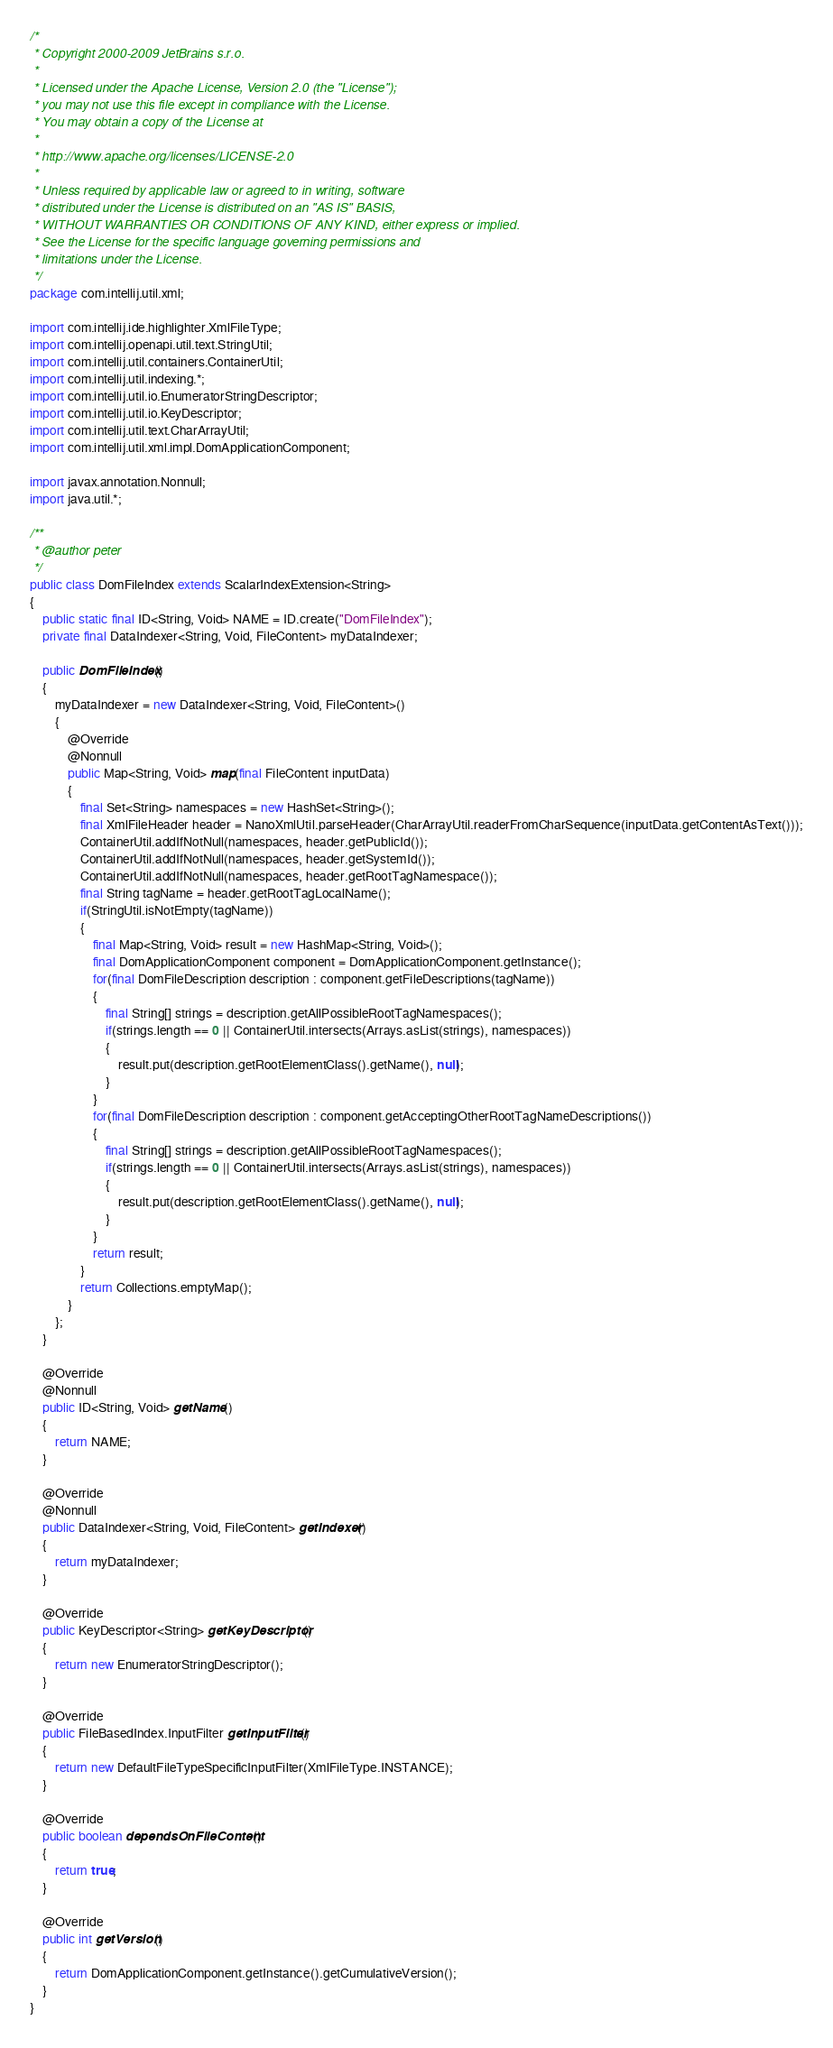<code> <loc_0><loc_0><loc_500><loc_500><_Java_>/*
 * Copyright 2000-2009 JetBrains s.r.o.
 *
 * Licensed under the Apache License, Version 2.0 (the "License");
 * you may not use this file except in compliance with the License.
 * You may obtain a copy of the License at
 *
 * http://www.apache.org/licenses/LICENSE-2.0
 *
 * Unless required by applicable law or agreed to in writing, software
 * distributed under the License is distributed on an "AS IS" BASIS,
 * WITHOUT WARRANTIES OR CONDITIONS OF ANY KIND, either express or implied.
 * See the License for the specific language governing permissions and
 * limitations under the License.
 */
package com.intellij.util.xml;

import com.intellij.ide.highlighter.XmlFileType;
import com.intellij.openapi.util.text.StringUtil;
import com.intellij.util.containers.ContainerUtil;
import com.intellij.util.indexing.*;
import com.intellij.util.io.EnumeratorStringDescriptor;
import com.intellij.util.io.KeyDescriptor;
import com.intellij.util.text.CharArrayUtil;
import com.intellij.util.xml.impl.DomApplicationComponent;

import javax.annotation.Nonnull;
import java.util.*;

/**
 * @author peter
 */
public class DomFileIndex extends ScalarIndexExtension<String>
{
	public static final ID<String, Void> NAME = ID.create("DomFileIndex");
	private final DataIndexer<String, Void, FileContent> myDataIndexer;

	public DomFileIndex()
	{
		myDataIndexer = new DataIndexer<String, Void, FileContent>()
		{
			@Override
			@Nonnull
			public Map<String, Void> map(final FileContent inputData)
			{
				final Set<String> namespaces = new HashSet<String>();
				final XmlFileHeader header = NanoXmlUtil.parseHeader(CharArrayUtil.readerFromCharSequence(inputData.getContentAsText()));
				ContainerUtil.addIfNotNull(namespaces, header.getPublicId());
				ContainerUtil.addIfNotNull(namespaces, header.getSystemId());
				ContainerUtil.addIfNotNull(namespaces, header.getRootTagNamespace());
				final String tagName = header.getRootTagLocalName();
				if(StringUtil.isNotEmpty(tagName))
				{
					final Map<String, Void> result = new HashMap<String, Void>();
					final DomApplicationComponent component = DomApplicationComponent.getInstance();
					for(final DomFileDescription description : component.getFileDescriptions(tagName))
					{
						final String[] strings = description.getAllPossibleRootTagNamespaces();
						if(strings.length == 0 || ContainerUtil.intersects(Arrays.asList(strings), namespaces))
						{
							result.put(description.getRootElementClass().getName(), null);
						}
					}
					for(final DomFileDescription description : component.getAcceptingOtherRootTagNameDescriptions())
					{
						final String[] strings = description.getAllPossibleRootTagNamespaces();
						if(strings.length == 0 || ContainerUtil.intersects(Arrays.asList(strings), namespaces))
						{
							result.put(description.getRootElementClass().getName(), null);
						}
					}
					return result;
				}
				return Collections.emptyMap();
			}
		};
	}

	@Override
	@Nonnull
	public ID<String, Void> getName()
	{
		return NAME;
	}

	@Override
	@Nonnull
	public DataIndexer<String, Void, FileContent> getIndexer()
	{
		return myDataIndexer;
	}

	@Override
	public KeyDescriptor<String> getKeyDescriptor()
	{
		return new EnumeratorStringDescriptor();
	}

	@Override
	public FileBasedIndex.InputFilter getInputFilter()
	{
		return new DefaultFileTypeSpecificInputFilter(XmlFileType.INSTANCE);
	}

	@Override
	public boolean dependsOnFileContent()
	{
		return true;
	}

	@Override
	public int getVersion()
	{
		return DomApplicationComponent.getInstance().getCumulativeVersion();
	}
}
</code> 